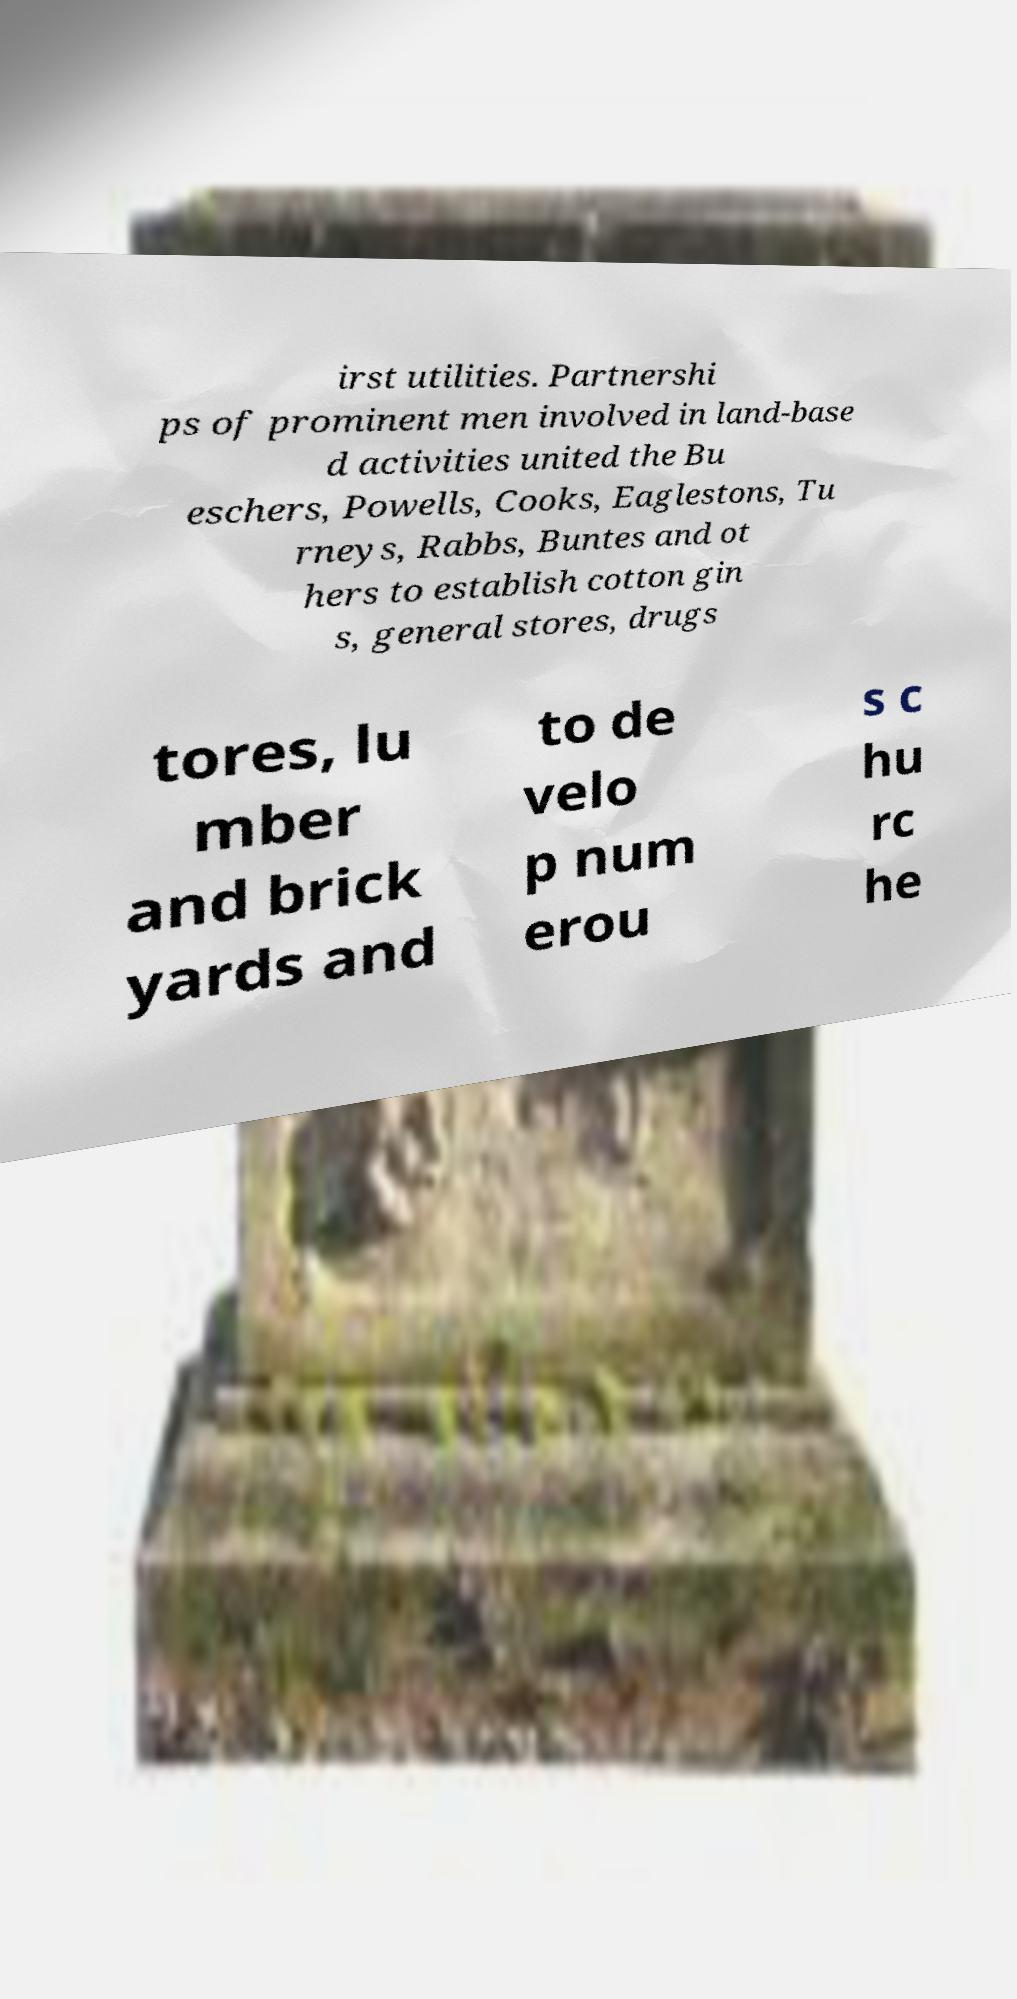I need the written content from this picture converted into text. Can you do that? irst utilities. Partnershi ps of prominent men involved in land-base d activities united the Bu eschers, Powells, Cooks, Eaglestons, Tu rneys, Rabbs, Buntes and ot hers to establish cotton gin s, general stores, drugs tores, lu mber and brick yards and to de velo p num erou s c hu rc he 